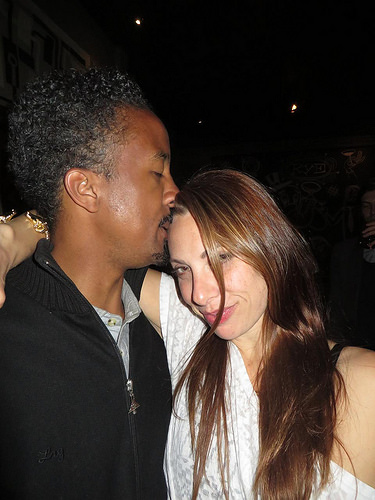<image>
Can you confirm if the girl is on the man? Yes. Looking at the image, I can see the girl is positioned on top of the man, with the man providing support. Is there a man to the right of the lady? Yes. From this viewpoint, the man is positioned to the right side relative to the lady. Is the lady in front of the man? No. The lady is not in front of the man. The spatial positioning shows a different relationship between these objects. 